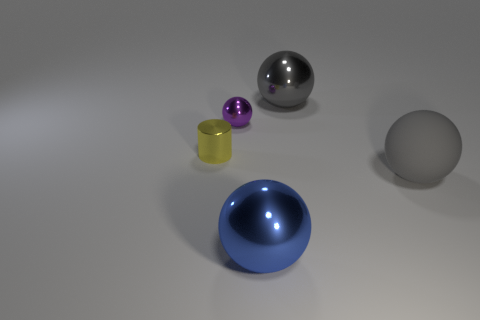Subtract all cyan cylinders. Subtract all gray balls. How many cylinders are left? 1 Subtract all yellow cubes. How many brown balls are left? 0 Add 2 tiny greens. How many big grays exist? 0 Subtract all gray metal balls. Subtract all matte objects. How many objects are left? 3 Add 4 tiny metal spheres. How many tiny metal spheres are left? 5 Add 2 large gray objects. How many large gray objects exist? 4 Add 1 small brown matte things. How many objects exist? 6 Subtract all gray balls. How many balls are left? 2 Subtract all small shiny balls. How many balls are left? 3 Subtract 1 gray spheres. How many objects are left? 4 